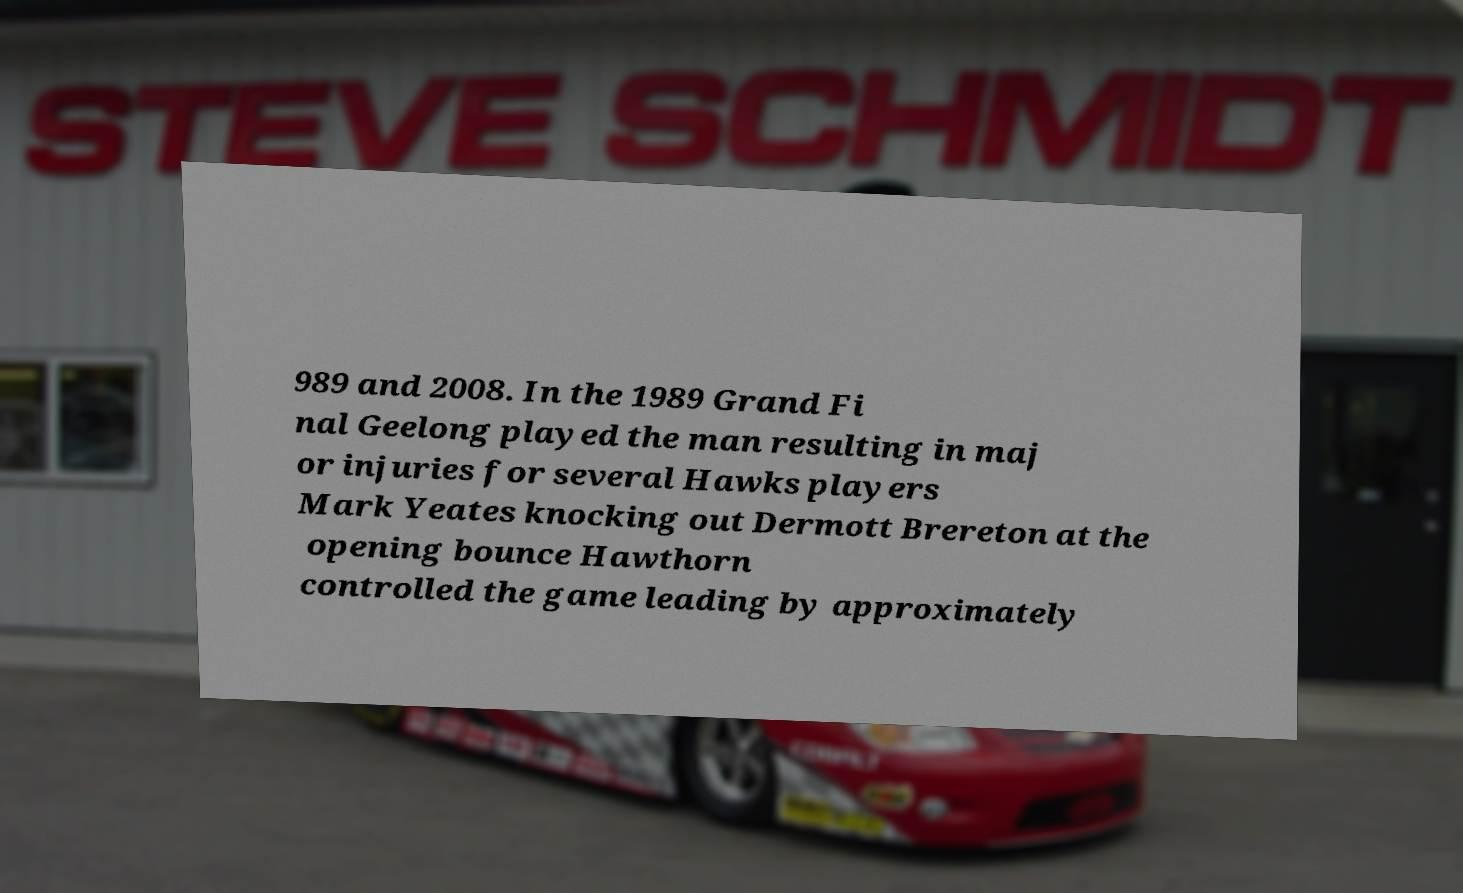Please read and relay the text visible in this image. What does it say? 989 and 2008. In the 1989 Grand Fi nal Geelong played the man resulting in maj or injuries for several Hawks players Mark Yeates knocking out Dermott Brereton at the opening bounce Hawthorn controlled the game leading by approximately 